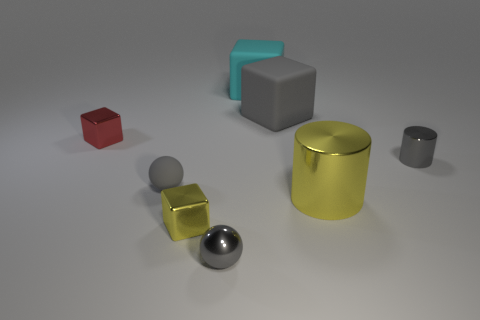Subtract 1 blocks. How many blocks are left? 3 Subtract all blue blocks. Subtract all cyan cylinders. How many blocks are left? 4 Add 1 tiny cylinders. How many objects exist? 9 Subtract all spheres. How many objects are left? 6 Add 5 tiny gray cylinders. How many tiny gray cylinders are left? 6 Add 2 big cyan matte balls. How many big cyan matte balls exist? 2 Subtract 1 gray cylinders. How many objects are left? 7 Subtract all gray blocks. Subtract all large purple rubber cylinders. How many objects are left? 7 